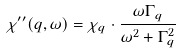<formula> <loc_0><loc_0><loc_500><loc_500>\chi ^ { \prime \prime } ( q , \omega ) = \chi _ { q } \cdot \frac { \omega \Gamma _ { q } } { \omega ^ { 2 } + \Gamma _ { q } ^ { 2 } }</formula> 